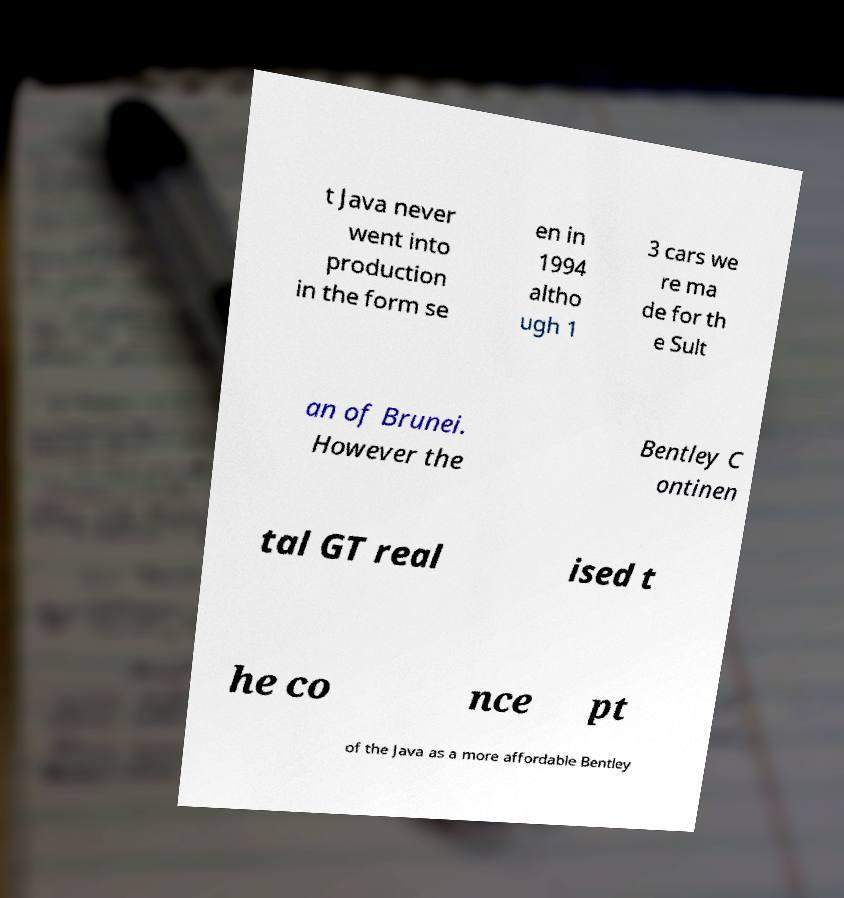What messages or text are displayed in this image? I need them in a readable, typed format. t Java never went into production in the form se en in 1994 altho ugh 1 3 cars we re ma de for th e Sult an of Brunei. However the Bentley C ontinen tal GT real ised t he co nce pt of the Java as a more affordable Bentley 